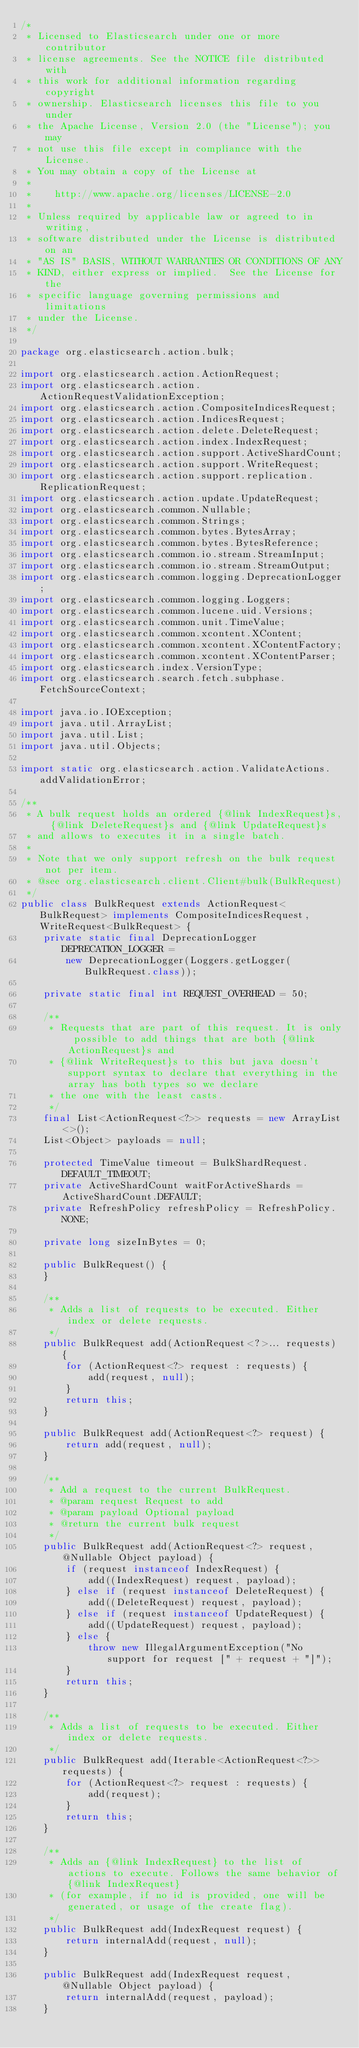<code> <loc_0><loc_0><loc_500><loc_500><_Java_>/*
 * Licensed to Elasticsearch under one or more contributor
 * license agreements. See the NOTICE file distributed with
 * this work for additional information regarding copyright
 * ownership. Elasticsearch licenses this file to you under
 * the Apache License, Version 2.0 (the "License"); you may
 * not use this file except in compliance with the License.
 * You may obtain a copy of the License at
 *
 *    http://www.apache.org/licenses/LICENSE-2.0
 *
 * Unless required by applicable law or agreed to in writing,
 * software distributed under the License is distributed on an
 * "AS IS" BASIS, WITHOUT WARRANTIES OR CONDITIONS OF ANY
 * KIND, either express or implied.  See the License for the
 * specific language governing permissions and limitations
 * under the License.
 */

package org.elasticsearch.action.bulk;

import org.elasticsearch.action.ActionRequest;
import org.elasticsearch.action.ActionRequestValidationException;
import org.elasticsearch.action.CompositeIndicesRequest;
import org.elasticsearch.action.IndicesRequest;
import org.elasticsearch.action.delete.DeleteRequest;
import org.elasticsearch.action.index.IndexRequest;
import org.elasticsearch.action.support.ActiveShardCount;
import org.elasticsearch.action.support.WriteRequest;
import org.elasticsearch.action.support.replication.ReplicationRequest;
import org.elasticsearch.action.update.UpdateRequest;
import org.elasticsearch.common.Nullable;
import org.elasticsearch.common.Strings;
import org.elasticsearch.common.bytes.BytesArray;
import org.elasticsearch.common.bytes.BytesReference;
import org.elasticsearch.common.io.stream.StreamInput;
import org.elasticsearch.common.io.stream.StreamOutput;
import org.elasticsearch.common.logging.DeprecationLogger;
import org.elasticsearch.common.logging.Loggers;
import org.elasticsearch.common.lucene.uid.Versions;
import org.elasticsearch.common.unit.TimeValue;
import org.elasticsearch.common.xcontent.XContent;
import org.elasticsearch.common.xcontent.XContentFactory;
import org.elasticsearch.common.xcontent.XContentParser;
import org.elasticsearch.index.VersionType;
import org.elasticsearch.search.fetch.subphase.FetchSourceContext;

import java.io.IOException;
import java.util.ArrayList;
import java.util.List;
import java.util.Objects;

import static org.elasticsearch.action.ValidateActions.addValidationError;

/**
 * A bulk request holds an ordered {@link IndexRequest}s, {@link DeleteRequest}s and {@link UpdateRequest}s
 * and allows to executes it in a single batch.
 *
 * Note that we only support refresh on the bulk request not per item.
 * @see org.elasticsearch.client.Client#bulk(BulkRequest)
 */
public class BulkRequest extends ActionRequest<BulkRequest> implements CompositeIndicesRequest, WriteRequest<BulkRequest> {
    private static final DeprecationLogger DEPRECATION_LOGGER =
        new DeprecationLogger(Loggers.getLogger(BulkRequest.class));

    private static final int REQUEST_OVERHEAD = 50;

    /**
     * Requests that are part of this request. It is only possible to add things that are both {@link ActionRequest}s and
     * {@link WriteRequest}s to this but java doesn't support syntax to declare that everything in the array has both types so we declare
     * the one with the least casts.
     */
    final List<ActionRequest<?>> requests = new ArrayList<>();
    List<Object> payloads = null;

    protected TimeValue timeout = BulkShardRequest.DEFAULT_TIMEOUT;
    private ActiveShardCount waitForActiveShards = ActiveShardCount.DEFAULT;
    private RefreshPolicy refreshPolicy = RefreshPolicy.NONE;

    private long sizeInBytes = 0;

    public BulkRequest() {
    }

    /**
     * Adds a list of requests to be executed. Either index or delete requests.
     */
    public BulkRequest add(ActionRequest<?>... requests) {
        for (ActionRequest<?> request : requests) {
            add(request, null);
        }
        return this;
    }

    public BulkRequest add(ActionRequest<?> request) {
        return add(request, null);
    }

    /**
     * Add a request to the current BulkRequest.
     * @param request Request to add
     * @param payload Optional payload
     * @return the current bulk request
     */
    public BulkRequest add(ActionRequest<?> request, @Nullable Object payload) {
        if (request instanceof IndexRequest) {
            add((IndexRequest) request, payload);
        } else if (request instanceof DeleteRequest) {
            add((DeleteRequest) request, payload);
        } else if (request instanceof UpdateRequest) {
            add((UpdateRequest) request, payload);
        } else {
            throw new IllegalArgumentException("No support for request [" + request + "]");
        }
        return this;
    }

    /**
     * Adds a list of requests to be executed. Either index or delete requests.
     */
    public BulkRequest add(Iterable<ActionRequest<?>> requests) {
        for (ActionRequest<?> request : requests) {
            add(request);
        }
        return this;
    }

    /**
     * Adds an {@link IndexRequest} to the list of actions to execute. Follows the same behavior of {@link IndexRequest}
     * (for example, if no id is provided, one will be generated, or usage of the create flag).
     */
    public BulkRequest add(IndexRequest request) {
        return internalAdd(request, null);
    }

    public BulkRequest add(IndexRequest request, @Nullable Object payload) {
        return internalAdd(request, payload);
    }
</code> 